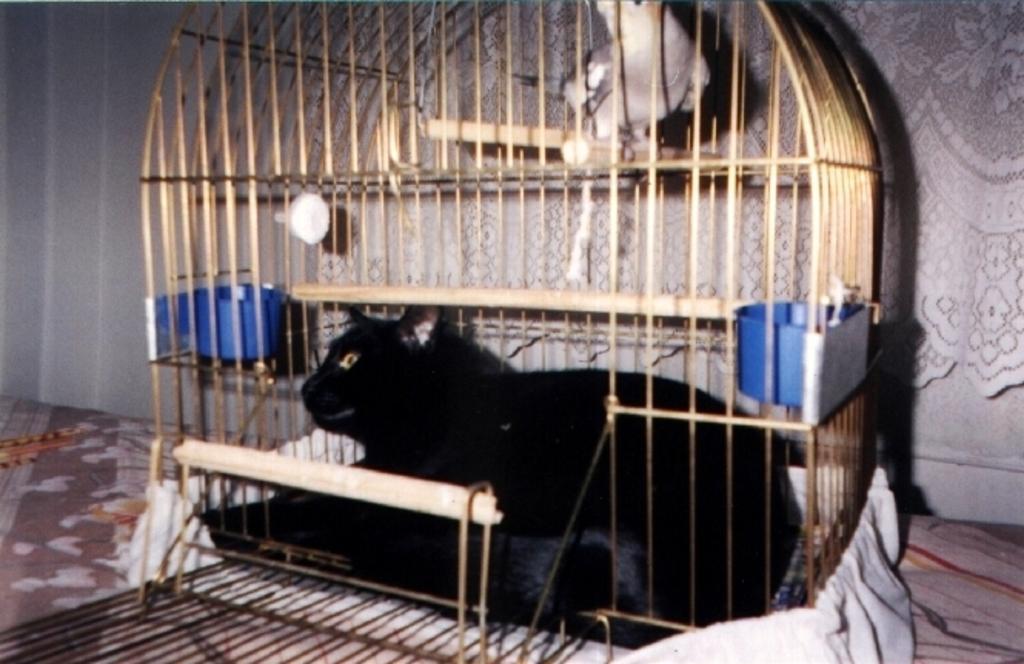How would you summarize this image in a sentence or two? It is a black color cat in a cage, at the top it's a parrot. 